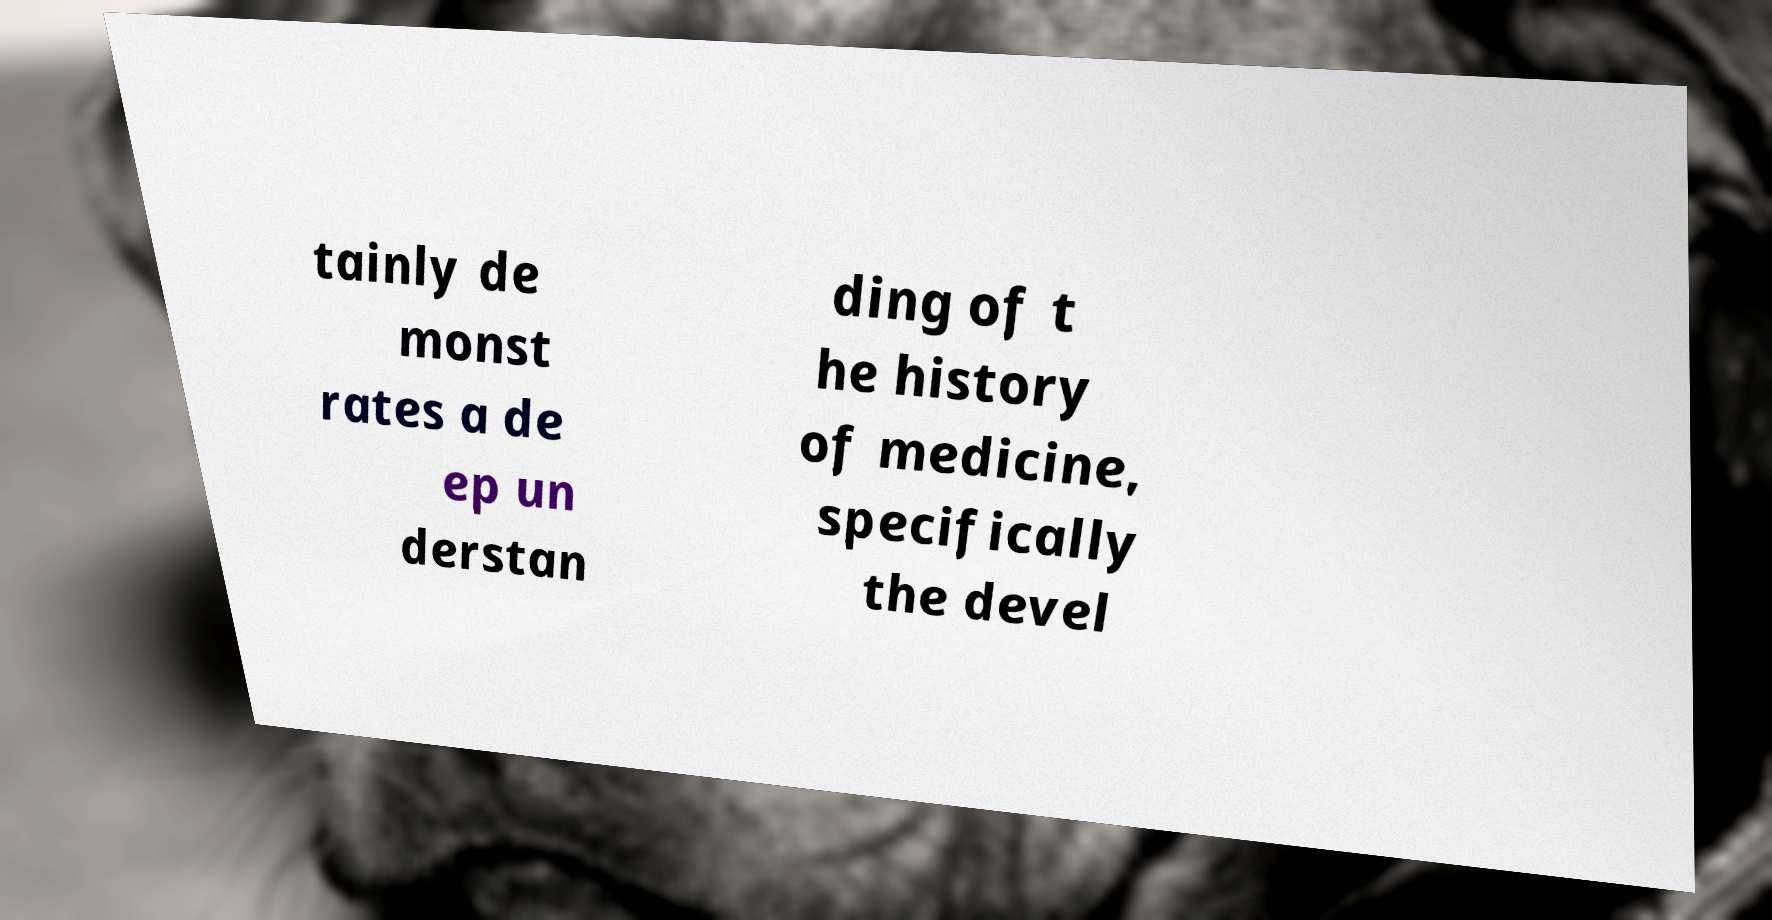Please read and relay the text visible in this image. What does it say? tainly de monst rates a de ep un derstan ding of t he history of medicine, specifically the devel 